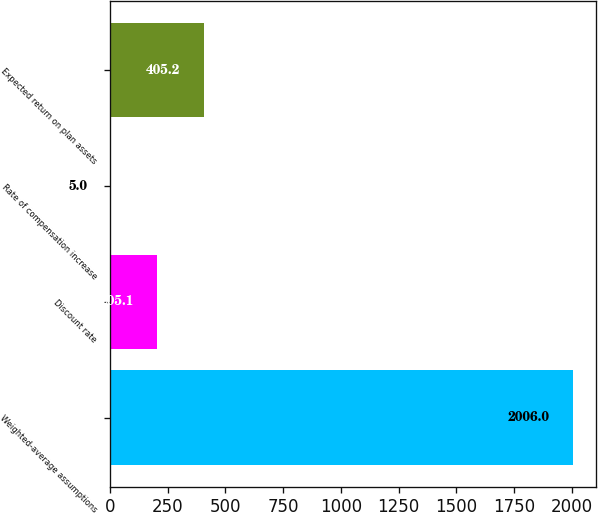Convert chart to OTSL. <chart><loc_0><loc_0><loc_500><loc_500><bar_chart><fcel>Weighted-average assumptions<fcel>Discount rate<fcel>Rate of compensation increase<fcel>Expected return on plan assets<nl><fcel>2006<fcel>205.1<fcel>5<fcel>405.2<nl></chart> 